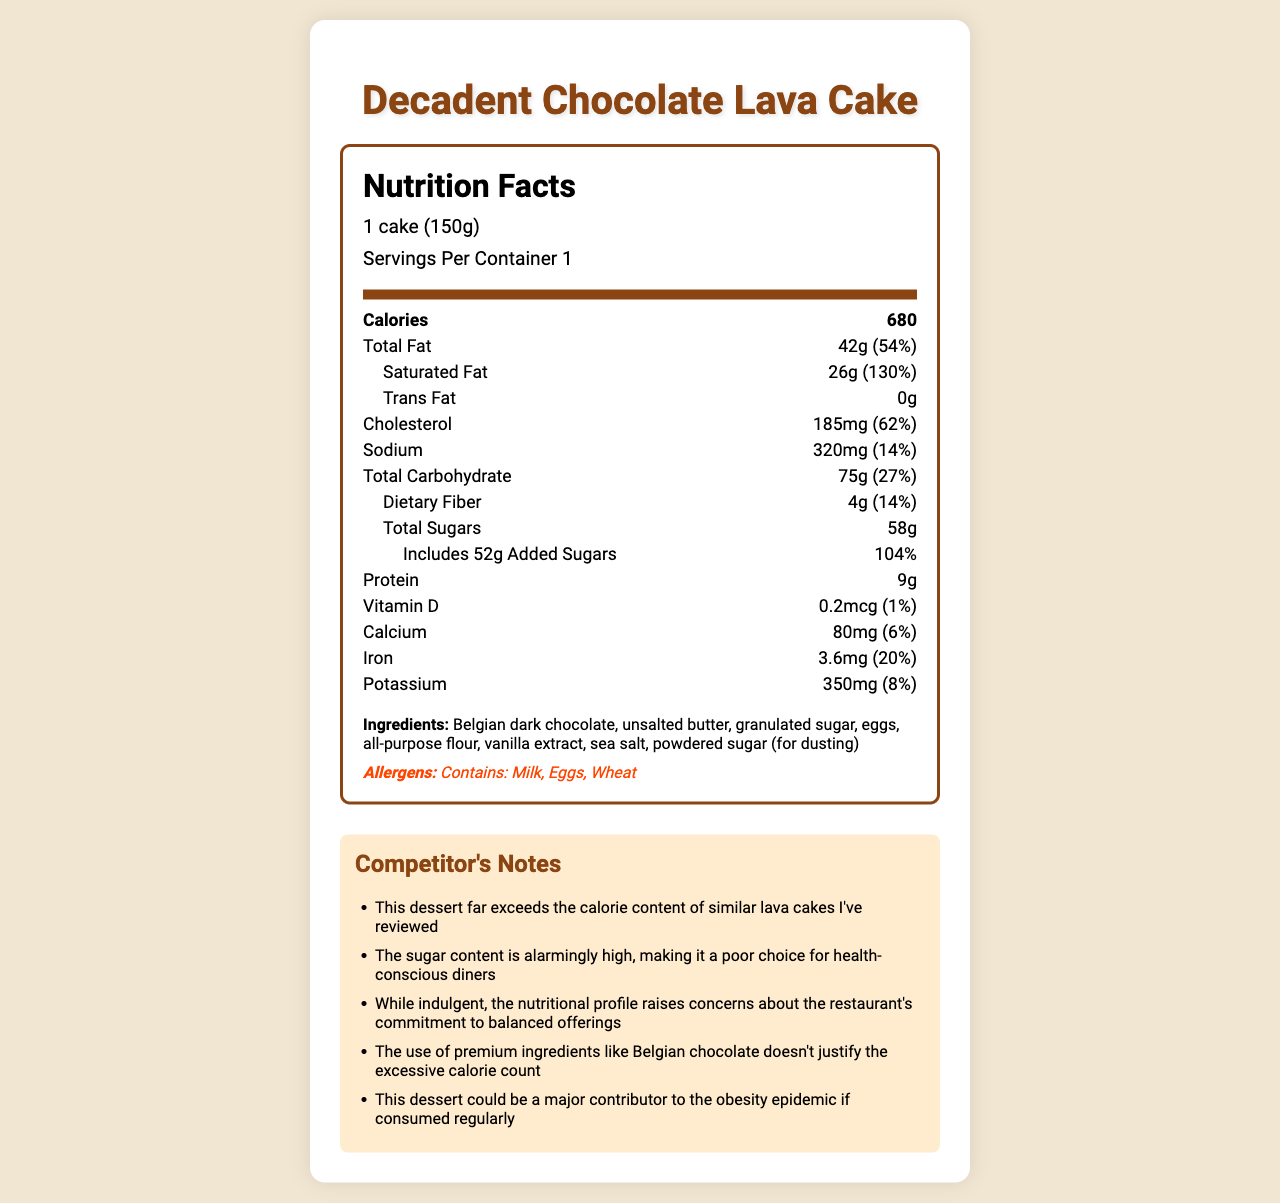what is the serving size of the Decadent Chocolate Lava Cake? The serving size is clearly stated as "1 cake (150g)" in the nutrition facts.
Answer: 1 cake (150g) how many grams of total sugars does the Decadent Chocolate Lava Cake contain? The total sugars are listed as "58g" in the nutrition facts section.
Answer: 58g what is the daily value percentage for added sugars? The daily value percentage for added sugars is shown as "104%" in the nutrition facts section.
Answer: 104% how much protein is in one serving of the Decadent Chocolate Lava Cake? The amount of protein per serving is stated as "9g" in the nutrition facts section.
Answer: 9g what are the three main allergens present in the Decadent Chocolate Lava Cake? The allergens are listed under the allergens section as "Contains: Milk, Eggs, Wheat".
Answer: Milk, Eggs, Wheat how many calories does one Decadent Chocolate Lava Cake contain? The calorie content per serving is listed as "680" in the nutrition facts section.
Answer: 680 which ingredient is not used in the Decadent Chocolate Lava Cake? A. Belgian dark chocolate B. Unsalted butter C. Almond flour Almond flour is not listed among the ingredients for the cake.
Answer: C which fact best describes the sodium content in the cake? I. The cake has 320mg of sodium II. The sodium daily value percentage is 8% III. The sodium daily value percentage is 14% The sodium content is 320mg and the daily value percentage listed is 14%.
Answer: I and III does the Decadent Chocolate Lava Cake contain any trans fat? The nutrition facts label mentions "Trans Fat 0g," indicating no trans fat.
Answer: No is the amount of dietary fiber in the cake sufficient for a balanced diet? The cake contains 4g of dietary fiber, which is 14% of the daily value, not substantial for a balanced diet.
Answer: No how does the saturated fat content compare with the daily value percentage? The saturated fat content is 26g, equating to 130% of the daily value, which is extremely high.
Answer: Very High what are the main points highlighted in the competitor notes? The competitor notes discuss the high calorie and sugar content, questioning the health aspect and criticizing the overuse of premium ingredients.
Answer: High calorie count, excessive sugar, poor health choice, and premium ingredients can't justify excess calories describe the main nutritional concerns about the Decadent Chocolate Lava Cake The document highlights the excessive calorie, sugar, and fat content, which severely outweighs any premium ingredient enhancements.
Answer: The cake is extremely high in calories (680), sugar (58g), and saturated fat (26g, 130% DV). It might be delicious with premium ingredients like Belgian chocolate but isn't a viable option for health-conscious individuals. how often should one consume the Decadent Chocolate Lava Cake according to dietary guidelines? The document does not provide specific dietary guidelines for the frequency of consumption.
Answer: Not enough information 